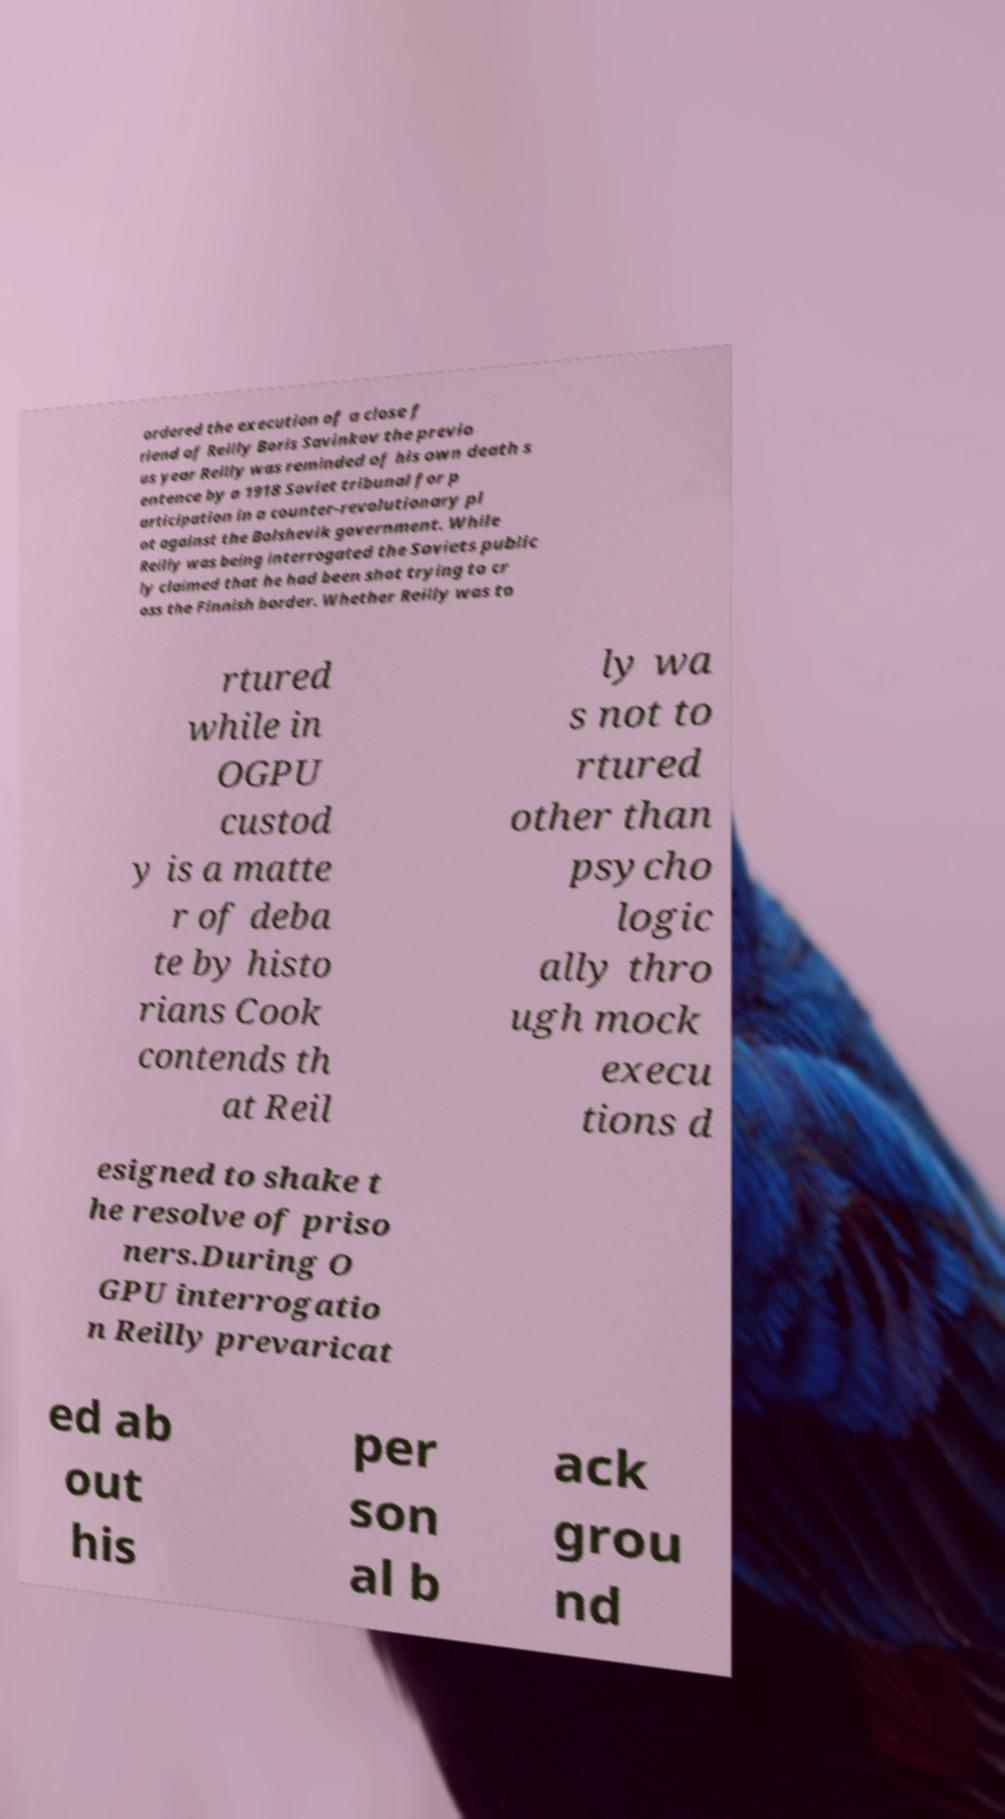For documentation purposes, I need the text within this image transcribed. Could you provide that? ordered the execution of a close f riend of Reilly Boris Savinkov the previo us year Reilly was reminded of his own death s entence by a 1918 Soviet tribunal for p articipation in a counter-revolutionary pl ot against the Bolshevik government. While Reilly was being interrogated the Soviets public ly claimed that he had been shot trying to cr oss the Finnish border. Whether Reilly was to rtured while in OGPU custod y is a matte r of deba te by histo rians Cook contends th at Reil ly wa s not to rtured other than psycho logic ally thro ugh mock execu tions d esigned to shake t he resolve of priso ners.During O GPU interrogatio n Reilly prevaricat ed ab out his per son al b ack grou nd 